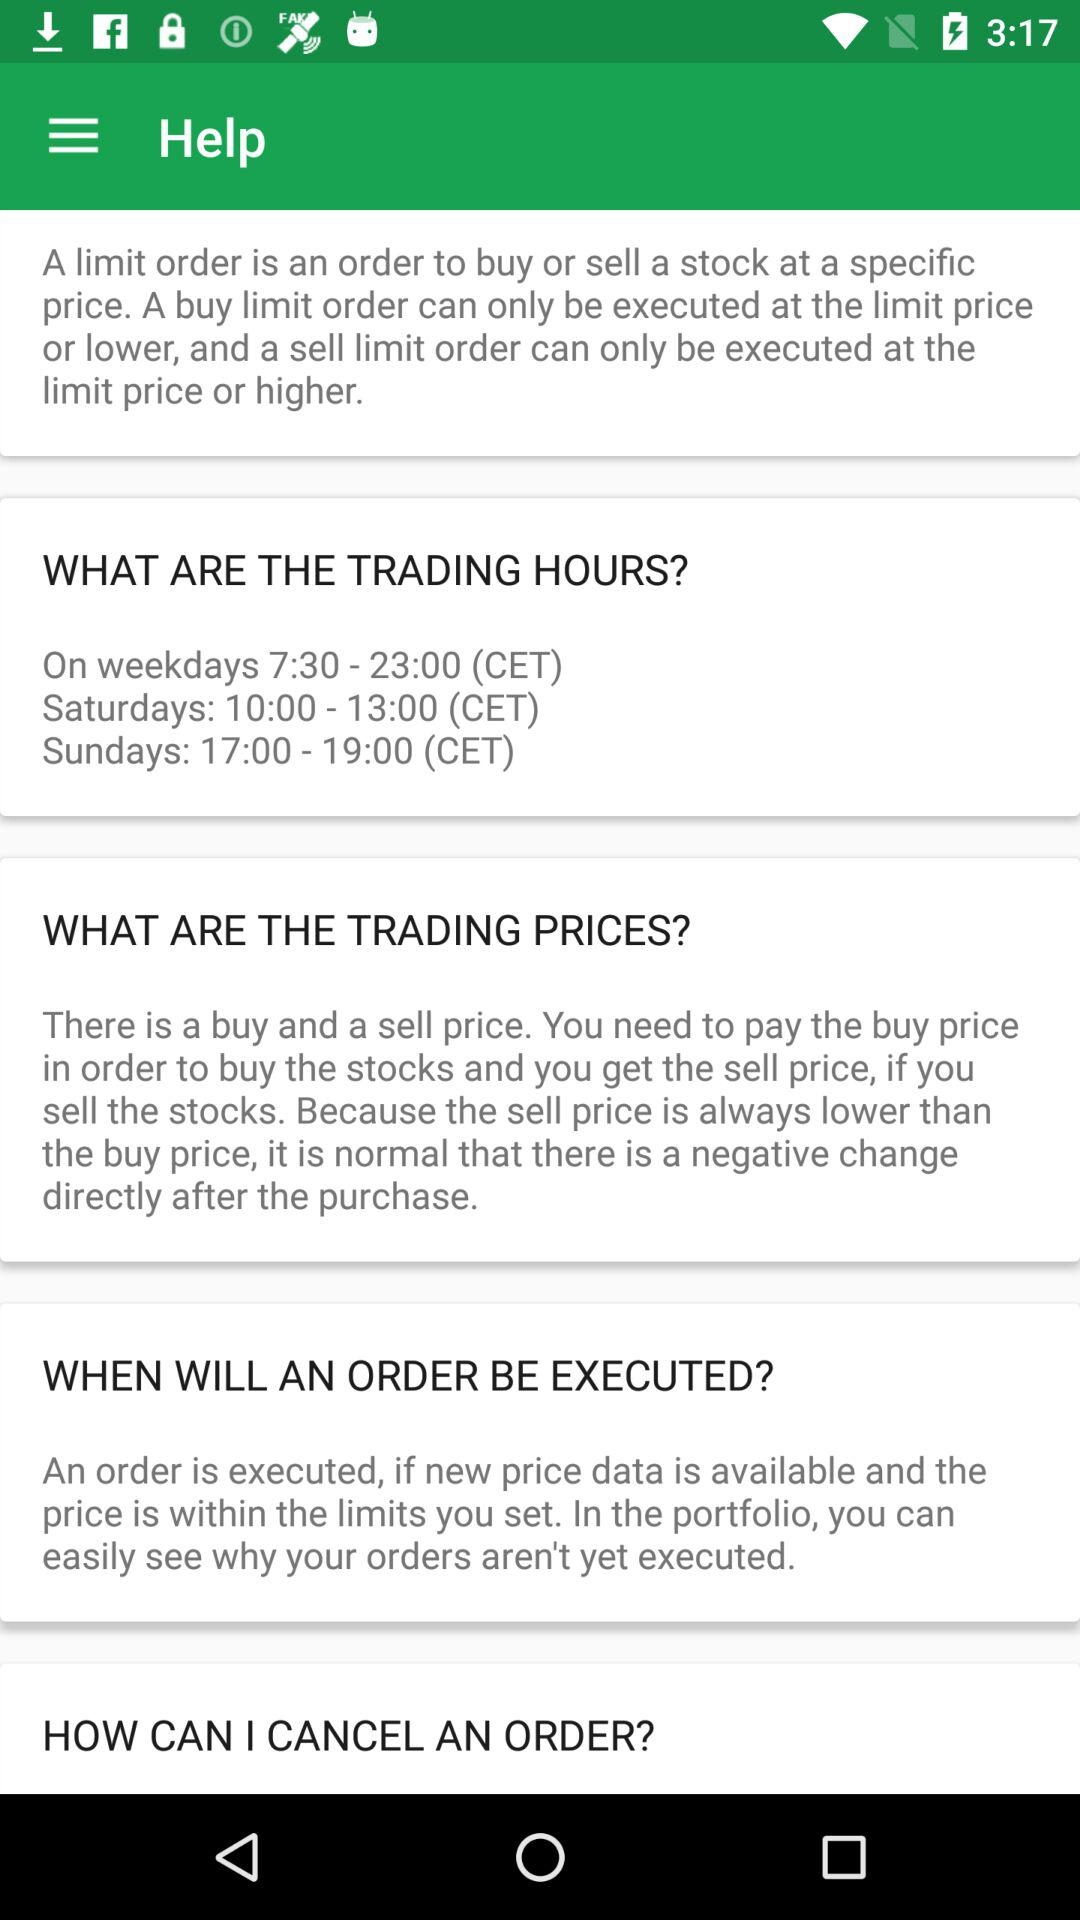What are the trading hours on Sundays? The trading hours on Sundays are between 17:00 and 19:00 CET. 